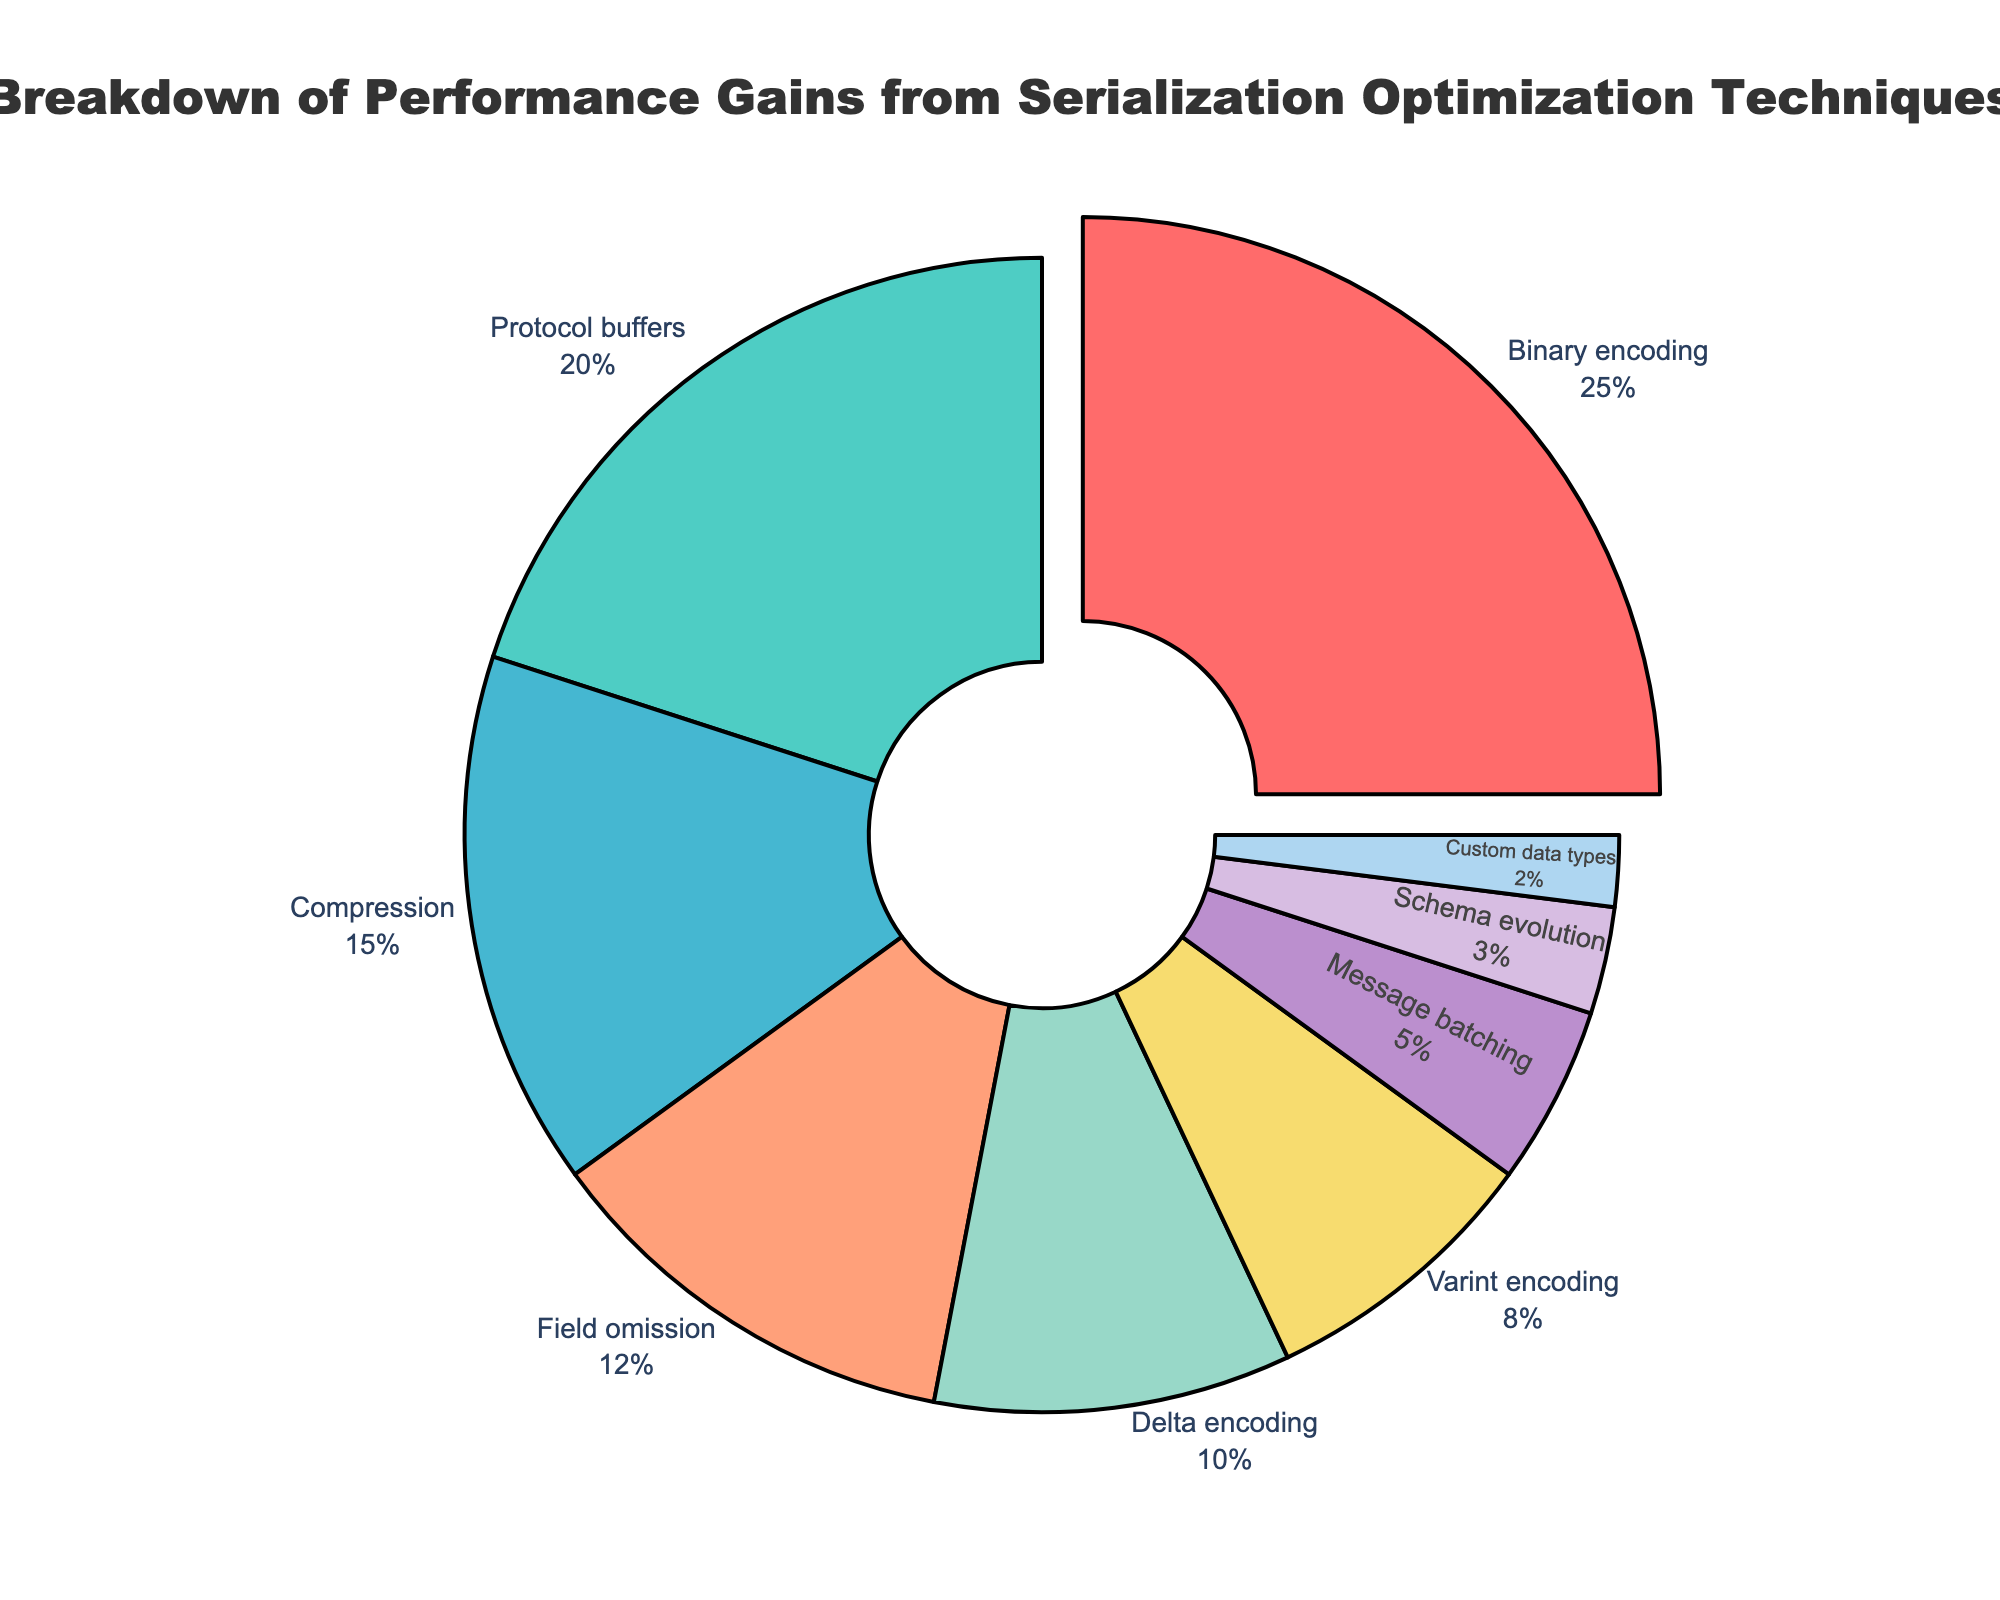What's the percentage gain from Binary encoding and Protocol buffers combined? To find the combined percentage gain from Binary encoding and Protocol buffers, add their individual percentages: 25% (Binary encoding) + 20% (Protocol buffers) = 45%.
Answer: 45% By how much does the percentage gain from Compression exceed the gain from Delta encoding? Subtract the percentage gain of Delta encoding from the percentage gain of Compression: 15% (Compression) - 10% (Delta encoding) = 5%.
Answer: 5% Which technique has the smallest percentage gain, and what is its value? The technique with the smallest percentage gain is Custom data types, which has a value of 2%.
Answer: Custom data types, 2% What is the ratio of the percentage gain from Varint encoding to that from Field omission? The percentage gain from Varint encoding is 8%, and from Field omission is 12%. The ratio is 8%/12% = 2/3.
Answer: 2:3 If you combine the percentage gains from the three techniques with the smallest shares, what is their total combined gain? The three techniques with the smallest shares are Schema evolution (3%), Custom data types (2%), and Message batching (5%). Summing them gives 3% + 2% + 5% = 10%.
Answer: 10% How does the percentage gain from Message batching compare to that from Varint encoding? The percentage gain from Message batching is 5%, which is less than the percentage gain from Varint encoding at 8%.
Answer: Less than Which technique is represented by light green color, and what is its percentage gain? The technique represented by light green color is Compression. Its percentage gain is 15%.
Answer: Compression, 15% What proportion of the total performance gain is provided by the top three techniques, and what are these techniques? The top three techniques are Binary encoding (25%), Protocol buffers (20%), and Compression (15%). The combined percentage is 25% + 20% + 15% = 60%, so they provide 60% of the total performance gain.
Answer: 60%, Binary encoding, Protocol buffers, Compression 